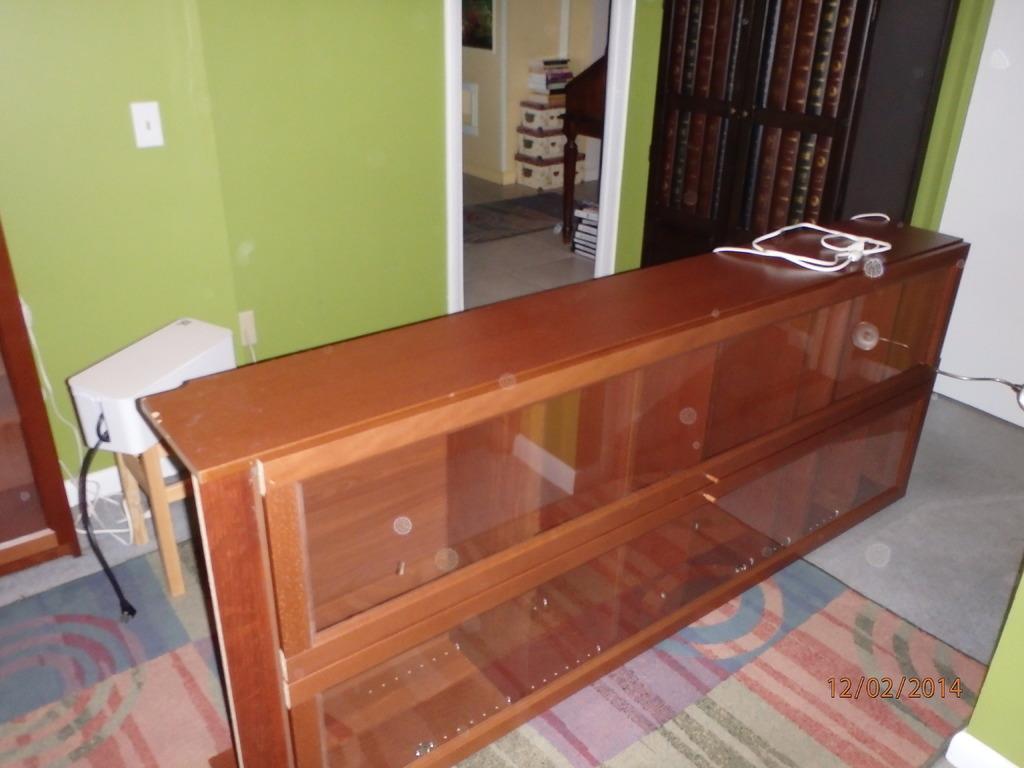In one or two sentences, can you explain what this image depicts? In this picture we can see a wooden cupboard with the glass doors. Behind the cupboard there is a table, some objects and a wall. On the image there is a watermark. 